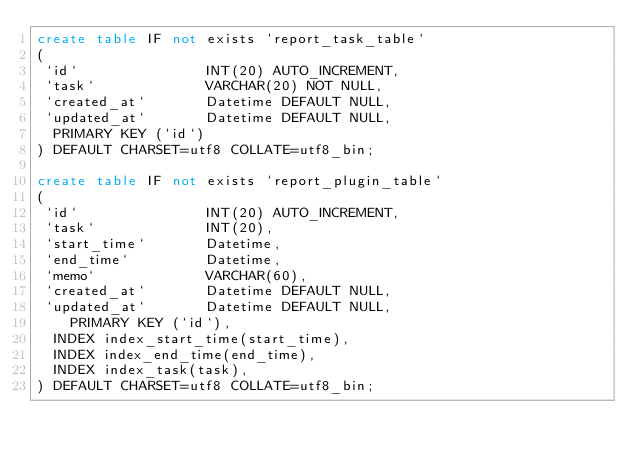Convert code to text. <code><loc_0><loc_0><loc_500><loc_500><_SQL_>create table IF not exists `report_task_table`
(
 `id`               INT(20) AUTO_INCREMENT,
 `task`             VARCHAR(20) NOT NULL,
 `created_at`       Datetime DEFAULT NULL,
 `updated_at`       Datetime DEFAULT NULL,
  PRIMARY KEY (`id`)
) DEFAULT CHARSET=utf8 COLLATE=utf8_bin;

create table IF not exists `report_plugin_table`
(
 `id`               INT(20) AUTO_INCREMENT,
 `task`             INT(20),
 `start_time`       Datetime,
 `end_time`         Datetime,
 `memo`             VARCHAR(60),
 `created_at`       Datetime DEFAULT NULL,
 `updated_at`       Datetime DEFAULT NULL,
    PRIMARY KEY (`id`),
  INDEX index_start_time(start_time),
  INDEX index_end_time(end_time),
  INDEX index_task(task),
) DEFAULT CHARSET=utf8 COLLATE=utf8_bin;

</code> 